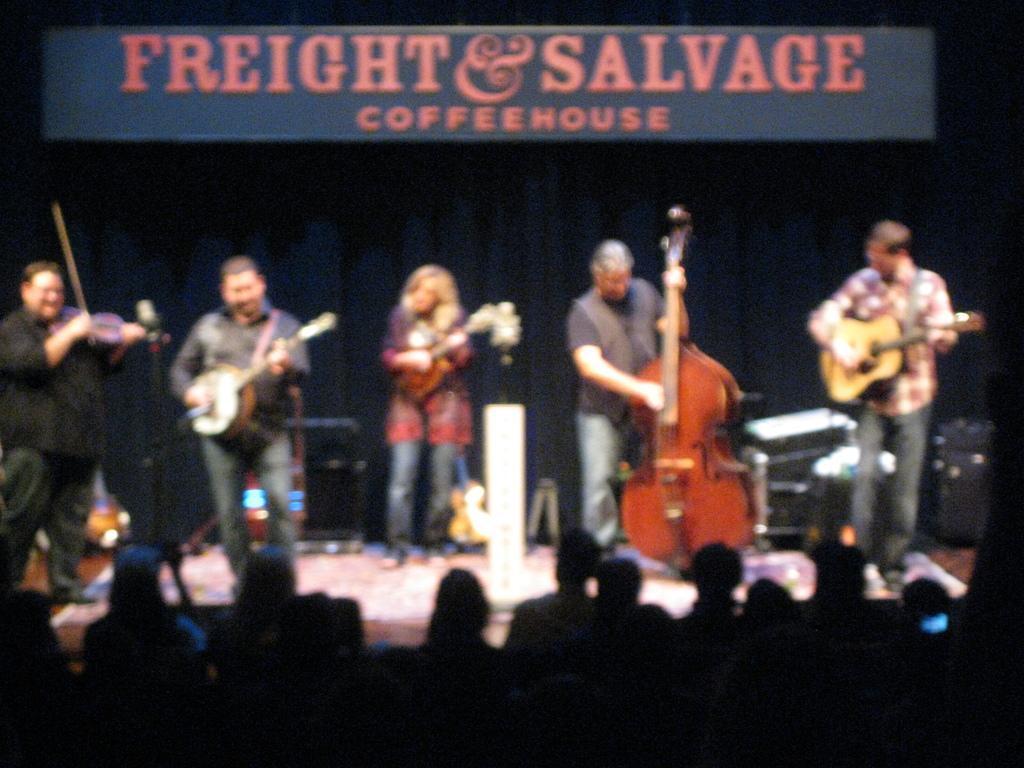Can you describe this image briefly? In this image I can see number of people are standing and holding musical instruments. I can also see here few people are sitting. 